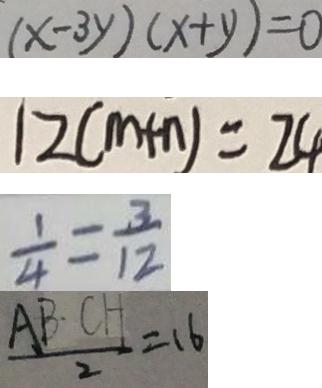Convert formula to latex. <formula><loc_0><loc_0><loc_500><loc_500>( x - 3 y ) ( x + y ) = 0 
 1 2 ( m + n ) = 2 4 
 \frac { 1 } { 4 } = \frac { 3 } { 1 2 } 
 \frac { A B \cdot C H } { 2 } = 1 6</formula> 